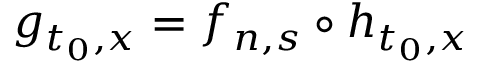<formula> <loc_0><loc_0><loc_500><loc_500>g _ { t _ { 0 } , x } = f _ { n , s } \circ h _ { t _ { 0 } , x }</formula> 